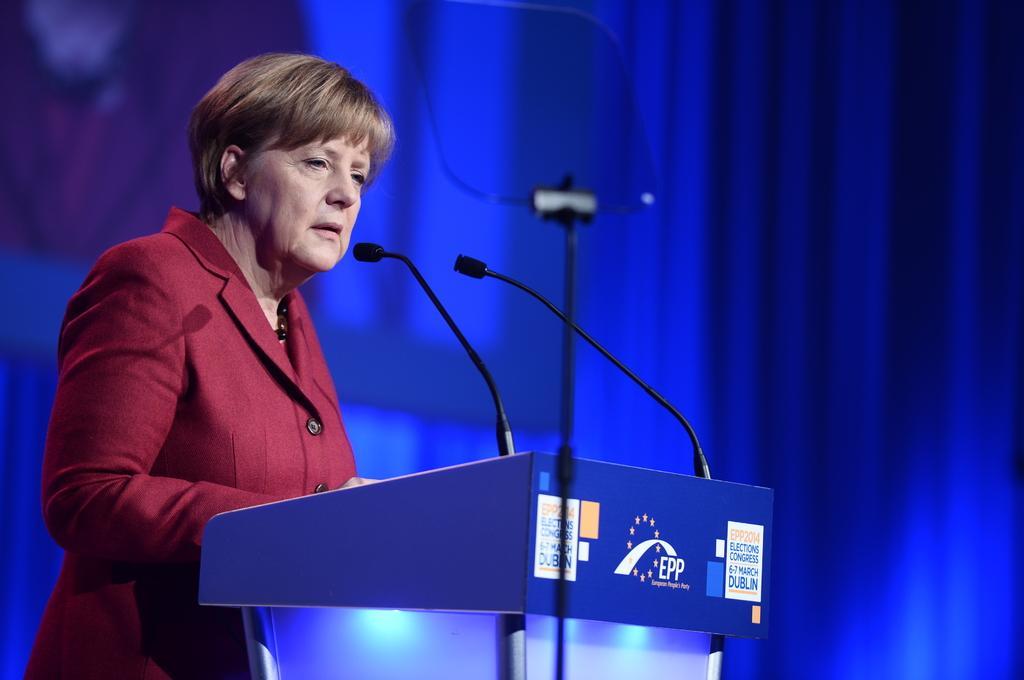Can you describe this image briefly? In this image I can see an old woman is standing near the podium and speaking into microphone. She wore dark red color coat and there is a blue color background in this image. 